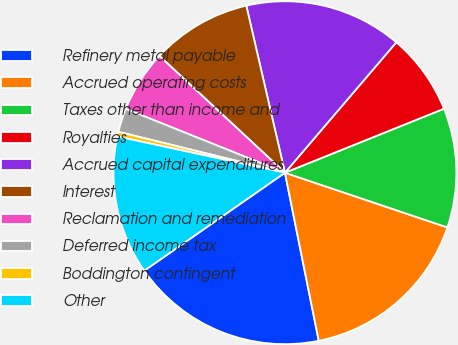<chart> <loc_0><loc_0><loc_500><loc_500><pie_chart><fcel>Refinery metal payable<fcel>Accrued operating costs<fcel>Taxes other than income and<fcel>Royalties<fcel>Accrued capital expenditures<fcel>Interest<fcel>Reclamation and remediation<fcel>Deferred income tax<fcel>Boddington contingent<fcel>Other<nl><fcel>18.48%<fcel>16.67%<fcel>11.26%<fcel>7.66%<fcel>14.87%<fcel>9.46%<fcel>5.85%<fcel>2.24%<fcel>0.44%<fcel>13.07%<nl></chart> 